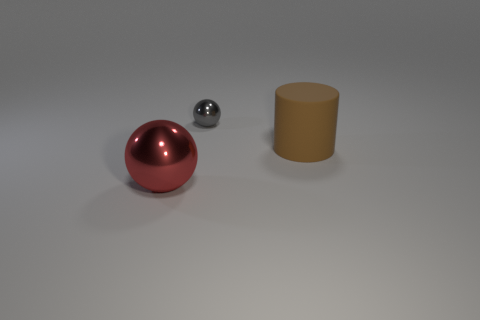Is there anything else that is the same material as the brown object?
Your response must be concise. No. What is the object that is both left of the brown rubber cylinder and to the right of the large metal thing made of?
Your response must be concise. Metal. There is a small gray object; does it have the same shape as the big thing on the left side of the tiny metallic thing?
Ensure brevity in your answer.  Yes. How many cubes are small gray metal things or large green matte objects?
Make the answer very short. 0. There is a large thing that is in front of the large rubber thing; what shape is it?
Keep it short and to the point. Sphere. What number of tiny gray spheres have the same material as the big red object?
Ensure brevity in your answer.  1. Is the number of brown rubber objects that are in front of the large red shiny thing less than the number of metal things?
Make the answer very short. Yes. What size is the sphere behind the object that is left of the tiny ball?
Ensure brevity in your answer.  Small. There is a red sphere that is the same size as the brown cylinder; what material is it?
Provide a succinct answer. Metal. Is the number of gray metallic things that are in front of the gray shiny sphere less than the number of gray things that are on the right side of the big red sphere?
Ensure brevity in your answer.  Yes. 